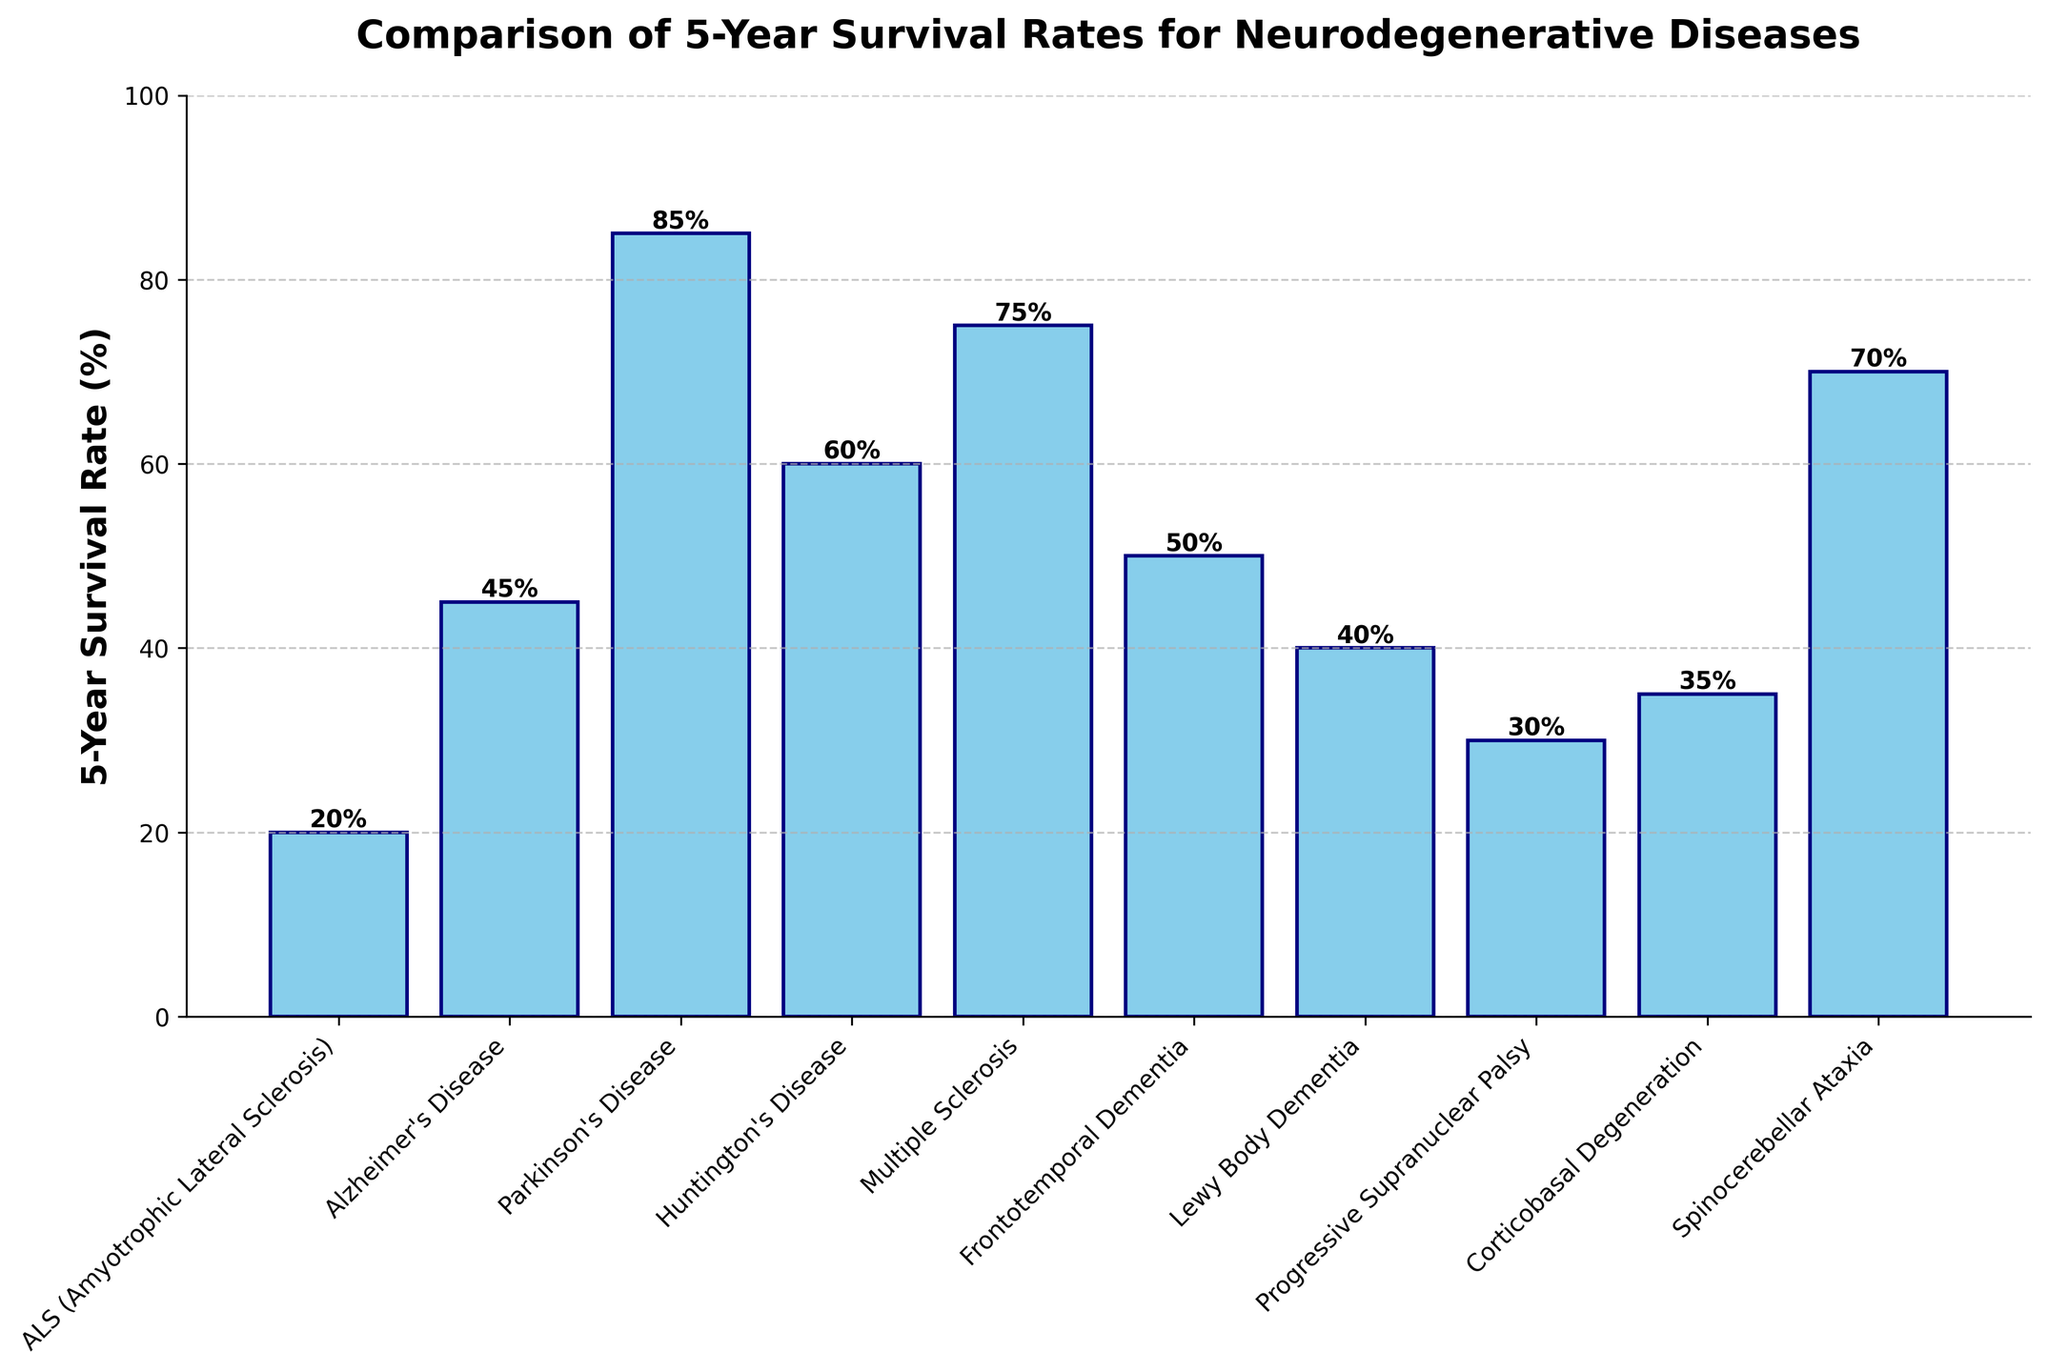Which neurodegenerative disease has the highest 5-year survival rate? By examining the height of the bars in the chart, we can see that Parkinson's Disease has the tallest bar, indicating the highest 5-year survival rate.
Answer: Parkinson's Disease Which disease has a lower 5-year survival rate: Lewy Body Dementia or Corticobasal Degeneration? By comparing the heights of the bars, Lewy Body Dementia has a shorter bar compared to Corticobasal Degeneration, indicating a lower 5-year survival rate.
Answer: Lewy Body Dementia What's the difference in 5-year survival rates between ALS and Huntington's Disease? ALS has a survival rate of 20%, and Huntington's Disease has a survival rate of 60%. The difference is calculated as 60% - 20%.
Answer: 40% What is the average 5-year survival rate of Alzheimer's Disease, Huntington's Disease, and Multiple Sclerosis? Sum the survival rates of these diseases (45% + 60% + 75%) and divide by the number of diseases (3). The average is 180% / 3.
Answer: 60% Which disease has the closest 5-year survival rate to Multiple Sclerosis? By comparing the bar heights visually, Spinocerebellar Ataxia, with a 70% rate, is closest to the 75% survival rate of Multiple Sclerosis.
Answer: Spinocerebellar Ataxia Order the diseases by their 5-year survival rates from highest to lowest. By organizing the diseases according to the heights of their bars: Parkinson's Disease (85%), Spinocerebellar Ataxia (70%), Multiple Sclerosis (75%), Huntington's Disease (60%), Frontotemporal Dementia (50%), Alzheimer's Disease (45%), Corticobasal Degeneration (35%), Lewy Body Dementia (40%), Progressive Supranuclear Palsy (30%), ALS (20%).
Answer: Parkinson's Disease, Multiple Sclerosis, Spinocerebellar Ataxia, Huntington's Disease, Frontotemporal Dementia, Alzheimer's Disease, Lewy Body Dementia, Corticobasal Degeneration, Progressive Supranuclear Palsy, ALS What is the combined 5-year survival rate for ALS, Alzheimer's Disease, and Lewy Body Dementia? Adding these survival rates together: 20% (ALS) + 45% (Alzheimer's Disease) + 40% (Lewy Body Dementia) gives a combined rate.
Answer: 105% Which disease has a survival rate exactly 30%? By referring to the labels and the heights of the bars, Progressive Supranuclear Palsy has a survival rate of 30%.
Answer: Progressive Supranuclear Palsy How many diseases have a 5-year survival rate of 50% or more? Count the diseases with bars reaching or exceeding 50%: Alzheimer's Disease, Parkinson's Disease, Huntington's Disease, Multiple Sclerosis, Frontotemporal Dementia, and Spinocerebellar Ataxia. This totals 6 diseases.
Answer: 6 Which diseases have a 5-year survival rate higher than ALS but lower than 50%? ALS has a survival rate of 20%, and the diseases in this range are Corticobasal Degeneration (35%), Lewy Body Dementia (40%), and Progressive Supranuclear Palsy (30%).
Answer: Corticobasal Degeneration, Lewy Body Dementia, Progressive Supranuclear Palsy 